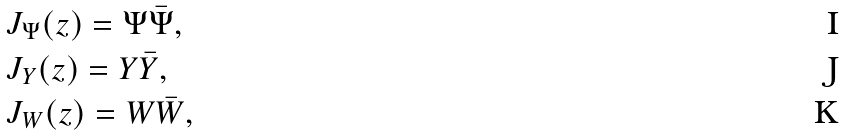<formula> <loc_0><loc_0><loc_500><loc_500>& J _ { \Psi } ( z ) = \Psi \bar { \Psi } , \\ & J _ { Y } ( z ) = Y \bar { Y } , \\ & J _ { W } ( z ) = W \bar { W } ,</formula> 